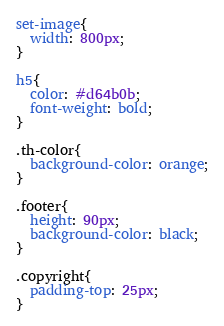<code> <loc_0><loc_0><loc_500><loc_500><_CSS_>
set-image{
  width: 800px;
}

h5{
  color: #d64b0b;
  font-weight: bold;
}

.th-color{
  background-color: orange;
}

.footer{
  height: 90px;
  background-color: black;
}

.copyright{
  padding-top: 25px;
}



</code> 